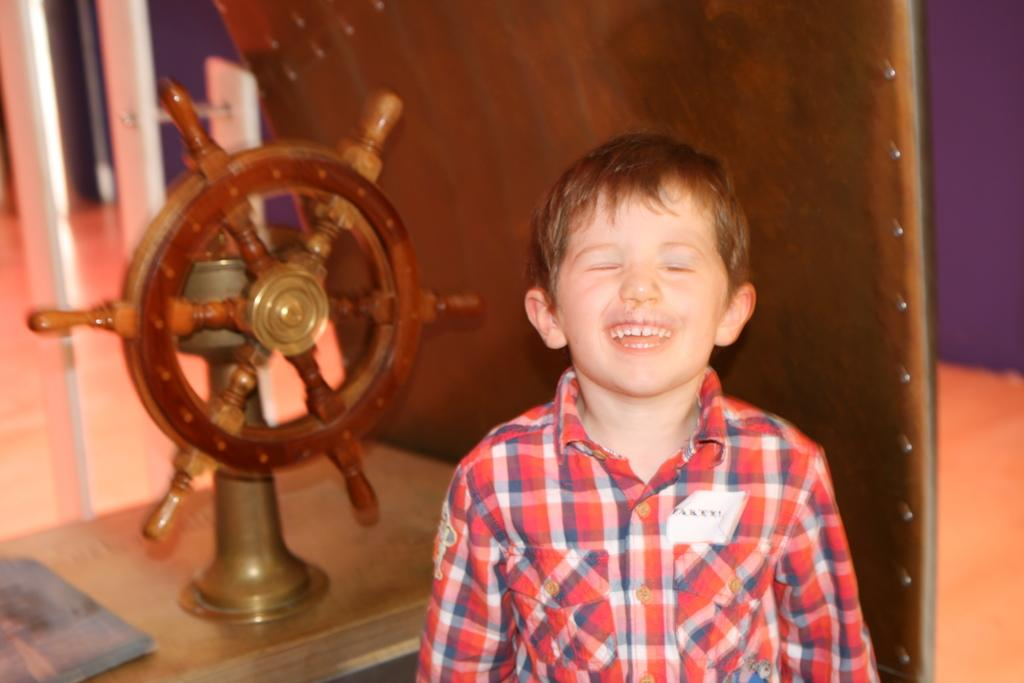Who is present in the image? There is a boy in the image. What object can be seen on a table in the image? There is a wheel on a table in the image. What type of jellyfish can be seen swimming in the image? There is no jellyfish present in the image; it features a boy and a wheel on a table. 